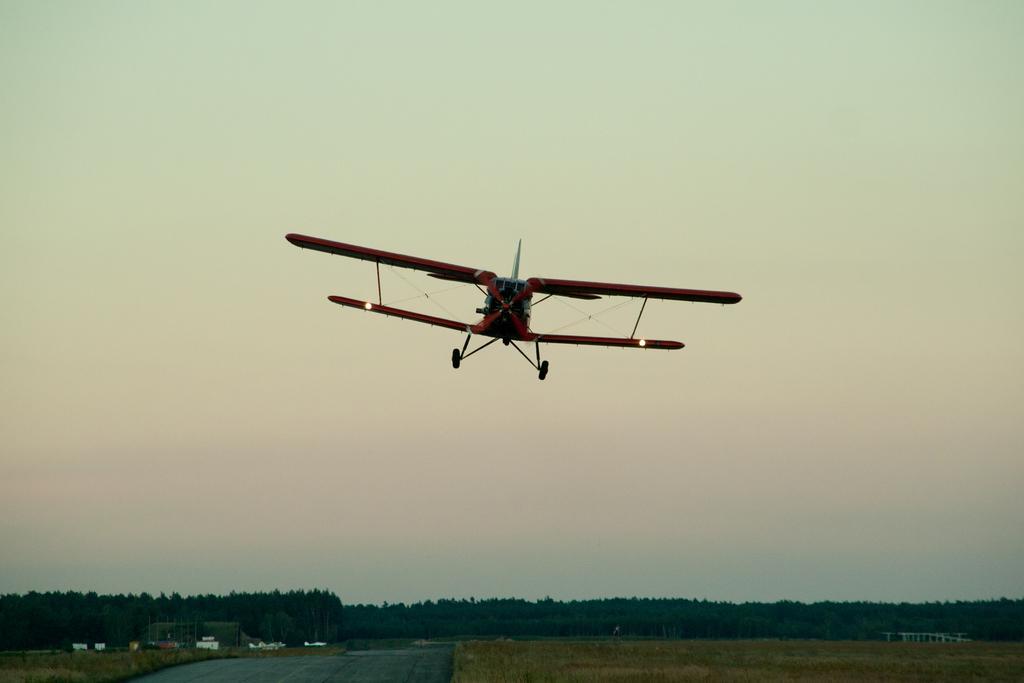How would you summarize this image in a sentence or two? There is an aircraft in the center of the image and there are trees, some objects and sky in the background area. 